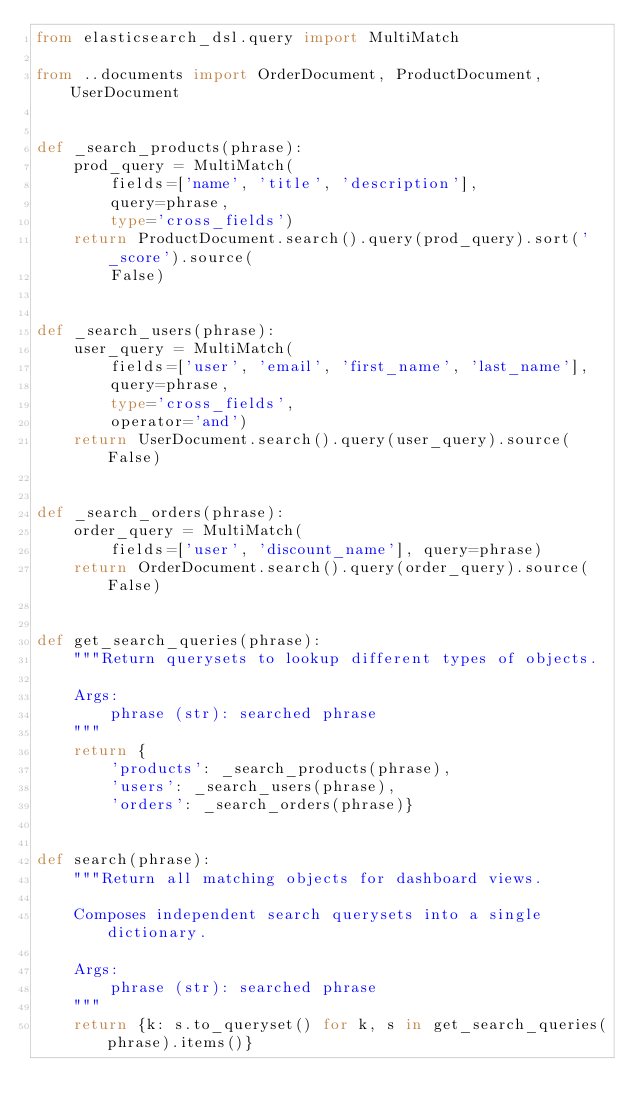<code> <loc_0><loc_0><loc_500><loc_500><_Python_>from elasticsearch_dsl.query import MultiMatch

from ..documents import OrderDocument, ProductDocument, UserDocument


def _search_products(phrase):
    prod_query = MultiMatch(
        fields=['name', 'title', 'description'],
        query=phrase,
        type='cross_fields')
    return ProductDocument.search().query(prod_query).sort('_score').source(
        False)


def _search_users(phrase):
    user_query = MultiMatch(
        fields=['user', 'email', 'first_name', 'last_name'],
        query=phrase,
        type='cross_fields',
        operator='and')
    return UserDocument.search().query(user_query).source(False)


def _search_orders(phrase):
    order_query = MultiMatch(
        fields=['user', 'discount_name'], query=phrase)
    return OrderDocument.search().query(order_query).source(False)


def get_search_queries(phrase):
    """Return querysets to lookup different types of objects.

    Args:
        phrase (str): searched phrase
    """
    return {
        'products': _search_products(phrase),
        'users': _search_users(phrase),
        'orders': _search_orders(phrase)}


def search(phrase):
    """Return all matching objects for dashboard views.

    Composes independent search querysets into a single dictionary.

    Args:
        phrase (str): searched phrase
    """
    return {k: s.to_queryset() for k, s in get_search_queries(phrase).items()}
</code> 